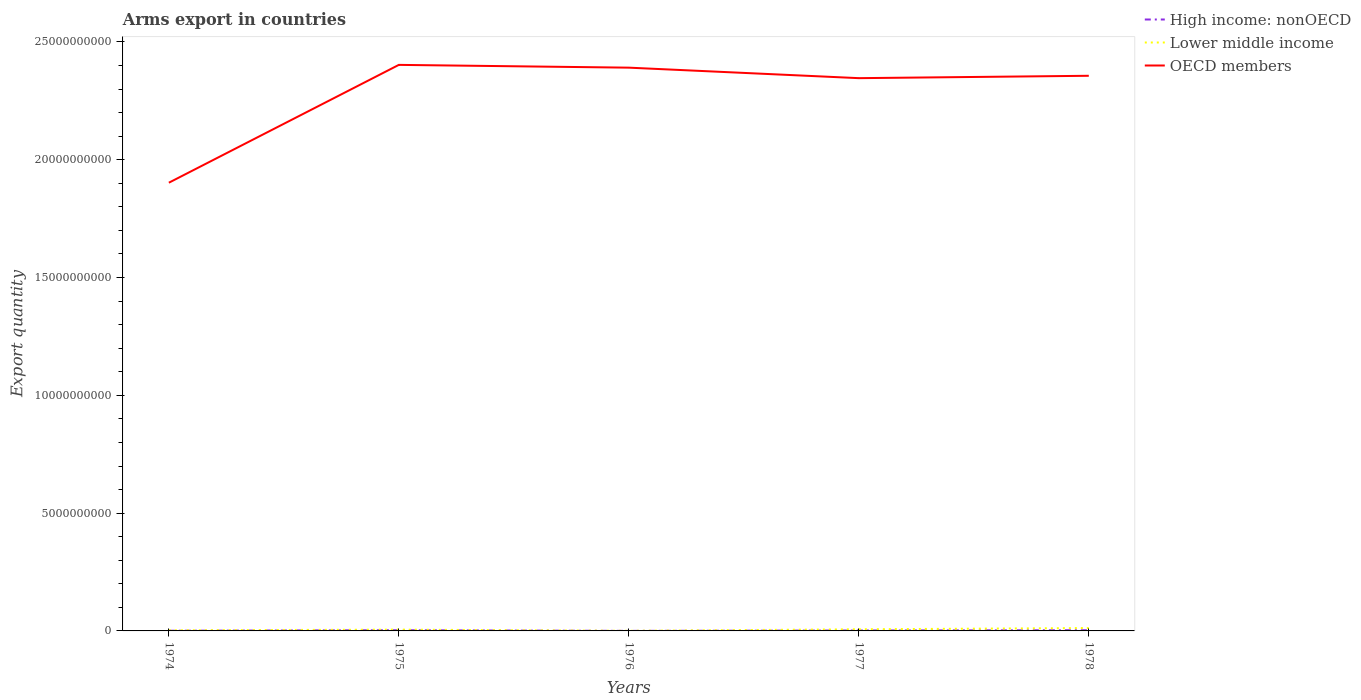Does the line corresponding to OECD members intersect with the line corresponding to Lower middle income?
Ensure brevity in your answer.  No. In which year was the total arms export in High income: nonOECD maximum?
Ensure brevity in your answer.  1976. What is the total total arms export in High income: nonOECD in the graph?
Give a very brief answer. 0. What is the difference between the highest and the second highest total arms export in OECD members?
Your answer should be compact. 5.00e+09. Is the total arms export in High income: nonOECD strictly greater than the total arms export in OECD members over the years?
Make the answer very short. Yes. How many lines are there?
Your answer should be compact. 3. Are the values on the major ticks of Y-axis written in scientific E-notation?
Your response must be concise. No. Does the graph contain grids?
Keep it short and to the point. No. What is the title of the graph?
Offer a terse response. Arms export in countries. What is the label or title of the X-axis?
Give a very brief answer. Years. What is the label or title of the Y-axis?
Your answer should be compact. Export quantity. What is the Export quantity in Lower middle income in 1974?
Your answer should be compact. 2.60e+07. What is the Export quantity in OECD members in 1974?
Provide a succinct answer. 1.90e+1. What is the Export quantity in High income: nonOECD in 1975?
Offer a very short reply. 3.00e+07. What is the Export quantity in Lower middle income in 1975?
Give a very brief answer. 5.50e+07. What is the Export quantity in OECD members in 1975?
Make the answer very short. 2.40e+1. What is the Export quantity in High income: nonOECD in 1976?
Offer a very short reply. 2.00e+06. What is the Export quantity in Lower middle income in 1976?
Provide a short and direct response. 5.00e+06. What is the Export quantity of OECD members in 1976?
Give a very brief answer. 2.39e+1. What is the Export quantity in High income: nonOECD in 1977?
Give a very brief answer. 1.80e+07. What is the Export quantity in Lower middle income in 1977?
Ensure brevity in your answer.  6.90e+07. What is the Export quantity of OECD members in 1977?
Your answer should be compact. 2.35e+1. What is the Export quantity in High income: nonOECD in 1978?
Give a very brief answer. 3.00e+07. What is the Export quantity in Lower middle income in 1978?
Your response must be concise. 1.22e+08. What is the Export quantity of OECD members in 1978?
Offer a terse response. 2.36e+1. Across all years, what is the maximum Export quantity in High income: nonOECD?
Keep it short and to the point. 3.00e+07. Across all years, what is the maximum Export quantity in Lower middle income?
Your answer should be very brief. 1.22e+08. Across all years, what is the maximum Export quantity of OECD members?
Your response must be concise. 2.40e+1. Across all years, what is the minimum Export quantity of High income: nonOECD?
Ensure brevity in your answer.  2.00e+06. Across all years, what is the minimum Export quantity of Lower middle income?
Ensure brevity in your answer.  5.00e+06. Across all years, what is the minimum Export quantity in OECD members?
Your response must be concise. 1.90e+1. What is the total Export quantity of High income: nonOECD in the graph?
Provide a short and direct response. 8.80e+07. What is the total Export quantity in Lower middle income in the graph?
Keep it short and to the point. 2.77e+08. What is the total Export quantity in OECD members in the graph?
Provide a succinct answer. 1.14e+11. What is the difference between the Export quantity in High income: nonOECD in 1974 and that in 1975?
Keep it short and to the point. -2.20e+07. What is the difference between the Export quantity of Lower middle income in 1974 and that in 1975?
Give a very brief answer. -2.90e+07. What is the difference between the Export quantity in OECD members in 1974 and that in 1975?
Provide a succinct answer. -5.00e+09. What is the difference between the Export quantity in High income: nonOECD in 1974 and that in 1976?
Provide a succinct answer. 6.00e+06. What is the difference between the Export quantity of Lower middle income in 1974 and that in 1976?
Your answer should be very brief. 2.10e+07. What is the difference between the Export quantity in OECD members in 1974 and that in 1976?
Your response must be concise. -4.88e+09. What is the difference between the Export quantity in High income: nonOECD in 1974 and that in 1977?
Your response must be concise. -1.00e+07. What is the difference between the Export quantity in Lower middle income in 1974 and that in 1977?
Your answer should be very brief. -4.30e+07. What is the difference between the Export quantity in OECD members in 1974 and that in 1977?
Make the answer very short. -4.44e+09. What is the difference between the Export quantity of High income: nonOECD in 1974 and that in 1978?
Your response must be concise. -2.20e+07. What is the difference between the Export quantity in Lower middle income in 1974 and that in 1978?
Provide a succinct answer. -9.60e+07. What is the difference between the Export quantity in OECD members in 1974 and that in 1978?
Offer a very short reply. -4.54e+09. What is the difference between the Export quantity in High income: nonOECD in 1975 and that in 1976?
Provide a succinct answer. 2.80e+07. What is the difference between the Export quantity in Lower middle income in 1975 and that in 1976?
Provide a short and direct response. 5.00e+07. What is the difference between the Export quantity of OECD members in 1975 and that in 1976?
Offer a terse response. 1.18e+08. What is the difference between the Export quantity of High income: nonOECD in 1975 and that in 1977?
Give a very brief answer. 1.20e+07. What is the difference between the Export quantity of Lower middle income in 1975 and that in 1977?
Your answer should be compact. -1.40e+07. What is the difference between the Export quantity of OECD members in 1975 and that in 1977?
Your answer should be very brief. 5.64e+08. What is the difference between the Export quantity of Lower middle income in 1975 and that in 1978?
Provide a succinct answer. -6.70e+07. What is the difference between the Export quantity in OECD members in 1975 and that in 1978?
Ensure brevity in your answer.  4.63e+08. What is the difference between the Export quantity in High income: nonOECD in 1976 and that in 1977?
Ensure brevity in your answer.  -1.60e+07. What is the difference between the Export quantity in Lower middle income in 1976 and that in 1977?
Make the answer very short. -6.40e+07. What is the difference between the Export quantity in OECD members in 1976 and that in 1977?
Make the answer very short. 4.46e+08. What is the difference between the Export quantity in High income: nonOECD in 1976 and that in 1978?
Make the answer very short. -2.80e+07. What is the difference between the Export quantity in Lower middle income in 1976 and that in 1978?
Provide a short and direct response. -1.17e+08. What is the difference between the Export quantity in OECD members in 1976 and that in 1978?
Ensure brevity in your answer.  3.45e+08. What is the difference between the Export quantity in High income: nonOECD in 1977 and that in 1978?
Your answer should be very brief. -1.20e+07. What is the difference between the Export quantity in Lower middle income in 1977 and that in 1978?
Your answer should be very brief. -5.30e+07. What is the difference between the Export quantity of OECD members in 1977 and that in 1978?
Give a very brief answer. -1.01e+08. What is the difference between the Export quantity in High income: nonOECD in 1974 and the Export quantity in Lower middle income in 1975?
Your response must be concise. -4.70e+07. What is the difference between the Export quantity in High income: nonOECD in 1974 and the Export quantity in OECD members in 1975?
Provide a succinct answer. -2.40e+1. What is the difference between the Export quantity in Lower middle income in 1974 and the Export quantity in OECD members in 1975?
Give a very brief answer. -2.40e+1. What is the difference between the Export quantity of High income: nonOECD in 1974 and the Export quantity of Lower middle income in 1976?
Give a very brief answer. 3.00e+06. What is the difference between the Export quantity of High income: nonOECD in 1974 and the Export quantity of OECD members in 1976?
Provide a succinct answer. -2.39e+1. What is the difference between the Export quantity of Lower middle income in 1974 and the Export quantity of OECD members in 1976?
Provide a succinct answer. -2.39e+1. What is the difference between the Export quantity in High income: nonOECD in 1974 and the Export quantity in Lower middle income in 1977?
Keep it short and to the point. -6.10e+07. What is the difference between the Export quantity in High income: nonOECD in 1974 and the Export quantity in OECD members in 1977?
Your response must be concise. -2.35e+1. What is the difference between the Export quantity in Lower middle income in 1974 and the Export quantity in OECD members in 1977?
Keep it short and to the point. -2.34e+1. What is the difference between the Export quantity in High income: nonOECD in 1974 and the Export quantity in Lower middle income in 1978?
Your response must be concise. -1.14e+08. What is the difference between the Export quantity of High income: nonOECD in 1974 and the Export quantity of OECD members in 1978?
Offer a terse response. -2.36e+1. What is the difference between the Export quantity in Lower middle income in 1974 and the Export quantity in OECD members in 1978?
Your answer should be very brief. -2.35e+1. What is the difference between the Export quantity in High income: nonOECD in 1975 and the Export quantity in Lower middle income in 1976?
Give a very brief answer. 2.50e+07. What is the difference between the Export quantity in High income: nonOECD in 1975 and the Export quantity in OECD members in 1976?
Your response must be concise. -2.39e+1. What is the difference between the Export quantity of Lower middle income in 1975 and the Export quantity of OECD members in 1976?
Offer a terse response. -2.39e+1. What is the difference between the Export quantity of High income: nonOECD in 1975 and the Export quantity of Lower middle income in 1977?
Your response must be concise. -3.90e+07. What is the difference between the Export quantity in High income: nonOECD in 1975 and the Export quantity in OECD members in 1977?
Offer a very short reply. -2.34e+1. What is the difference between the Export quantity in Lower middle income in 1975 and the Export quantity in OECD members in 1977?
Your answer should be compact. -2.34e+1. What is the difference between the Export quantity of High income: nonOECD in 1975 and the Export quantity of Lower middle income in 1978?
Offer a terse response. -9.20e+07. What is the difference between the Export quantity of High income: nonOECD in 1975 and the Export quantity of OECD members in 1978?
Your response must be concise. -2.35e+1. What is the difference between the Export quantity in Lower middle income in 1975 and the Export quantity in OECD members in 1978?
Make the answer very short. -2.35e+1. What is the difference between the Export quantity of High income: nonOECD in 1976 and the Export quantity of Lower middle income in 1977?
Your answer should be compact. -6.70e+07. What is the difference between the Export quantity in High income: nonOECD in 1976 and the Export quantity in OECD members in 1977?
Ensure brevity in your answer.  -2.35e+1. What is the difference between the Export quantity of Lower middle income in 1976 and the Export quantity of OECD members in 1977?
Your answer should be very brief. -2.35e+1. What is the difference between the Export quantity in High income: nonOECD in 1976 and the Export quantity in Lower middle income in 1978?
Provide a short and direct response. -1.20e+08. What is the difference between the Export quantity in High income: nonOECD in 1976 and the Export quantity in OECD members in 1978?
Your answer should be very brief. -2.36e+1. What is the difference between the Export quantity in Lower middle income in 1976 and the Export quantity in OECD members in 1978?
Provide a short and direct response. -2.36e+1. What is the difference between the Export quantity of High income: nonOECD in 1977 and the Export quantity of Lower middle income in 1978?
Your response must be concise. -1.04e+08. What is the difference between the Export quantity in High income: nonOECD in 1977 and the Export quantity in OECD members in 1978?
Offer a terse response. -2.35e+1. What is the difference between the Export quantity of Lower middle income in 1977 and the Export quantity of OECD members in 1978?
Your response must be concise. -2.35e+1. What is the average Export quantity of High income: nonOECD per year?
Your answer should be very brief. 1.76e+07. What is the average Export quantity in Lower middle income per year?
Offer a terse response. 5.54e+07. What is the average Export quantity of OECD members per year?
Offer a terse response. 2.28e+1. In the year 1974, what is the difference between the Export quantity of High income: nonOECD and Export quantity of Lower middle income?
Offer a terse response. -1.80e+07. In the year 1974, what is the difference between the Export quantity of High income: nonOECD and Export quantity of OECD members?
Provide a short and direct response. -1.90e+1. In the year 1974, what is the difference between the Export quantity in Lower middle income and Export quantity in OECD members?
Offer a very short reply. -1.90e+1. In the year 1975, what is the difference between the Export quantity in High income: nonOECD and Export quantity in Lower middle income?
Your answer should be very brief. -2.50e+07. In the year 1975, what is the difference between the Export quantity in High income: nonOECD and Export quantity in OECD members?
Provide a short and direct response. -2.40e+1. In the year 1975, what is the difference between the Export quantity in Lower middle income and Export quantity in OECD members?
Your answer should be compact. -2.40e+1. In the year 1976, what is the difference between the Export quantity in High income: nonOECD and Export quantity in OECD members?
Make the answer very short. -2.39e+1. In the year 1976, what is the difference between the Export quantity in Lower middle income and Export quantity in OECD members?
Your response must be concise. -2.39e+1. In the year 1977, what is the difference between the Export quantity of High income: nonOECD and Export quantity of Lower middle income?
Provide a short and direct response. -5.10e+07. In the year 1977, what is the difference between the Export quantity of High income: nonOECD and Export quantity of OECD members?
Your response must be concise. -2.34e+1. In the year 1977, what is the difference between the Export quantity in Lower middle income and Export quantity in OECD members?
Offer a very short reply. -2.34e+1. In the year 1978, what is the difference between the Export quantity in High income: nonOECD and Export quantity in Lower middle income?
Make the answer very short. -9.20e+07. In the year 1978, what is the difference between the Export quantity of High income: nonOECD and Export quantity of OECD members?
Offer a terse response. -2.35e+1. In the year 1978, what is the difference between the Export quantity in Lower middle income and Export quantity in OECD members?
Your answer should be compact. -2.34e+1. What is the ratio of the Export quantity of High income: nonOECD in 1974 to that in 1975?
Your answer should be compact. 0.27. What is the ratio of the Export quantity of Lower middle income in 1974 to that in 1975?
Offer a very short reply. 0.47. What is the ratio of the Export quantity in OECD members in 1974 to that in 1975?
Keep it short and to the point. 0.79. What is the ratio of the Export quantity in High income: nonOECD in 1974 to that in 1976?
Offer a terse response. 4. What is the ratio of the Export quantity of Lower middle income in 1974 to that in 1976?
Your answer should be compact. 5.2. What is the ratio of the Export quantity in OECD members in 1974 to that in 1976?
Your answer should be very brief. 0.8. What is the ratio of the Export quantity in High income: nonOECD in 1974 to that in 1977?
Your answer should be very brief. 0.44. What is the ratio of the Export quantity in Lower middle income in 1974 to that in 1977?
Keep it short and to the point. 0.38. What is the ratio of the Export quantity of OECD members in 1974 to that in 1977?
Offer a very short reply. 0.81. What is the ratio of the Export quantity in High income: nonOECD in 1974 to that in 1978?
Your response must be concise. 0.27. What is the ratio of the Export quantity of Lower middle income in 1974 to that in 1978?
Your response must be concise. 0.21. What is the ratio of the Export quantity of OECD members in 1974 to that in 1978?
Ensure brevity in your answer.  0.81. What is the ratio of the Export quantity in High income: nonOECD in 1975 to that in 1976?
Offer a terse response. 15. What is the ratio of the Export quantity in Lower middle income in 1975 to that in 1976?
Your answer should be compact. 11. What is the ratio of the Export quantity in Lower middle income in 1975 to that in 1977?
Keep it short and to the point. 0.8. What is the ratio of the Export quantity in High income: nonOECD in 1975 to that in 1978?
Your answer should be compact. 1. What is the ratio of the Export quantity of Lower middle income in 1975 to that in 1978?
Provide a succinct answer. 0.45. What is the ratio of the Export quantity of OECD members in 1975 to that in 1978?
Offer a terse response. 1.02. What is the ratio of the Export quantity of Lower middle income in 1976 to that in 1977?
Give a very brief answer. 0.07. What is the ratio of the Export quantity in High income: nonOECD in 1976 to that in 1978?
Your answer should be compact. 0.07. What is the ratio of the Export quantity of Lower middle income in 1976 to that in 1978?
Ensure brevity in your answer.  0.04. What is the ratio of the Export quantity of OECD members in 1976 to that in 1978?
Offer a very short reply. 1.01. What is the ratio of the Export quantity of Lower middle income in 1977 to that in 1978?
Offer a terse response. 0.57. What is the ratio of the Export quantity in OECD members in 1977 to that in 1978?
Your answer should be very brief. 1. What is the difference between the highest and the second highest Export quantity in Lower middle income?
Provide a succinct answer. 5.30e+07. What is the difference between the highest and the second highest Export quantity of OECD members?
Offer a very short reply. 1.18e+08. What is the difference between the highest and the lowest Export quantity in High income: nonOECD?
Offer a terse response. 2.80e+07. What is the difference between the highest and the lowest Export quantity in Lower middle income?
Offer a very short reply. 1.17e+08. What is the difference between the highest and the lowest Export quantity of OECD members?
Keep it short and to the point. 5.00e+09. 